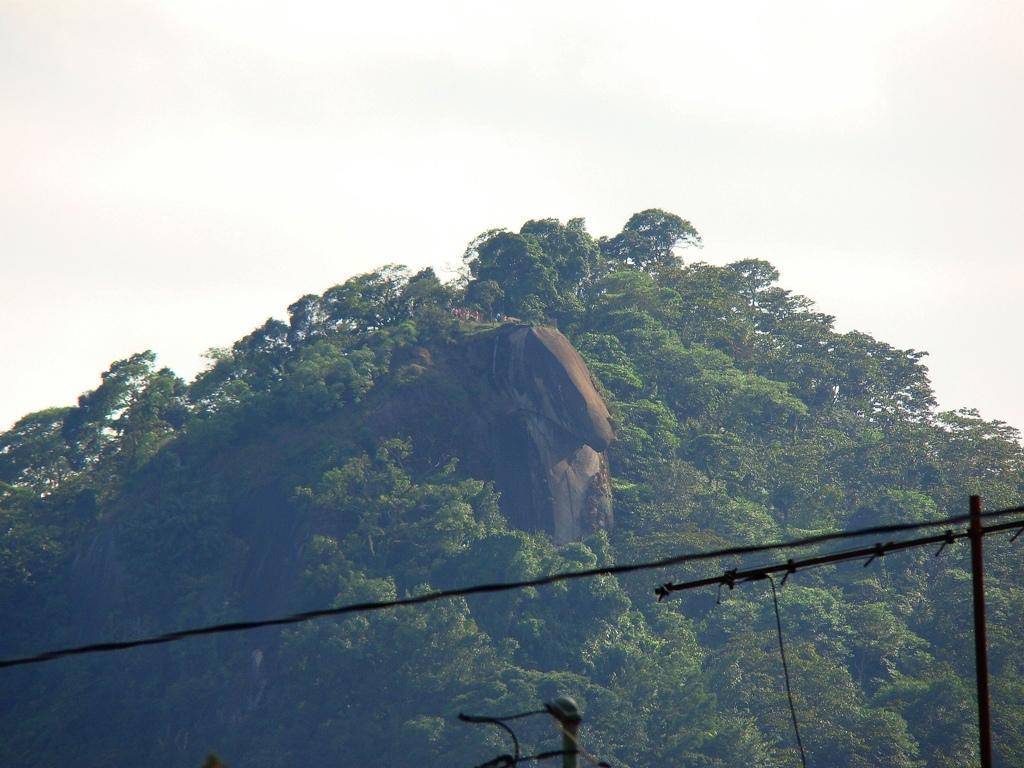Can you describe this image briefly? In the picture we can see a hill with trees and plants and in the background we can see a sky. 